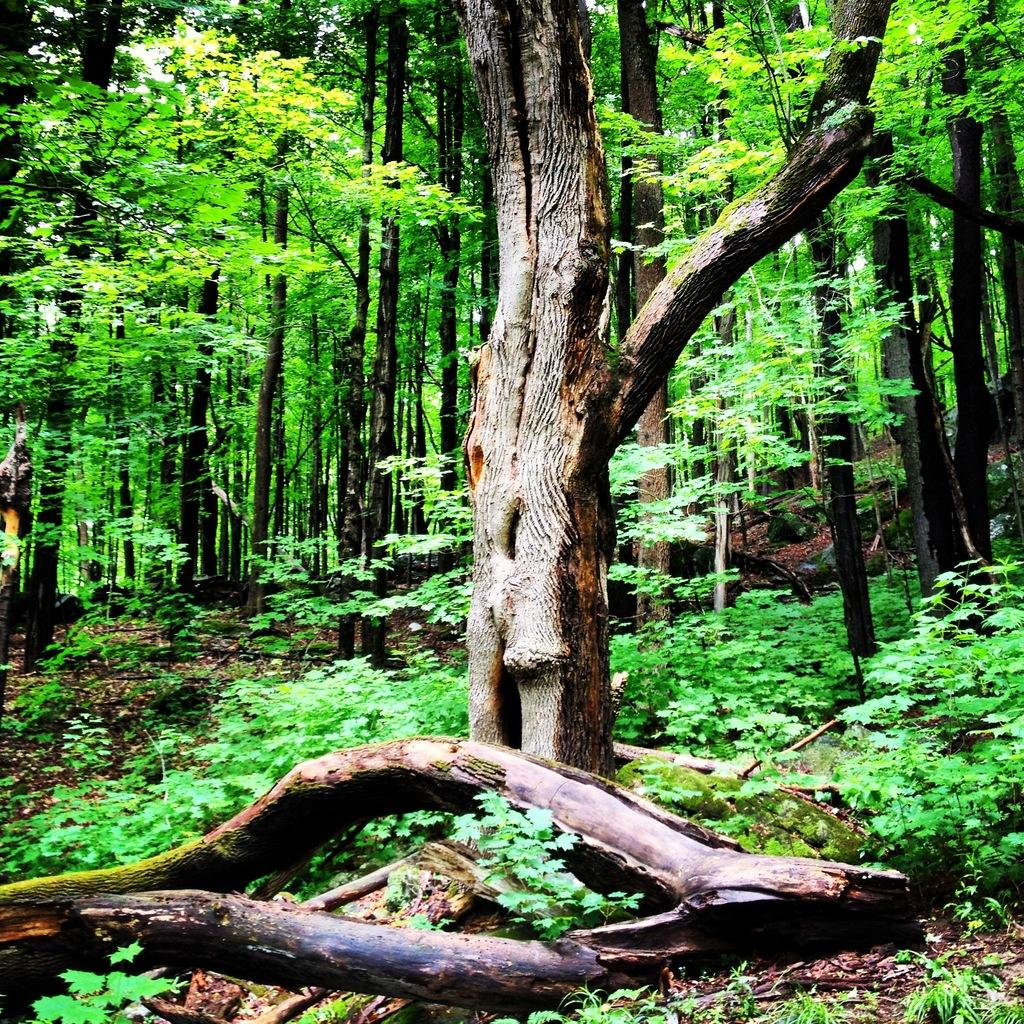What type of vegetation is on the ground in the image? There is grass on the ground in the image. What can be seen in the background of the image? There are trees in the background of the image. How would you describe the terrain in the image? The terrain appears to be flat, as there is no mention of a slope or any other elevation changes. How many police officers are visible in the image? There are no police officers present in the image; it features grass on the ground and trees in the background. What color is the grass in the image? The color of the grass cannot be determined from the image alone, as color information is not provided in the facts. 